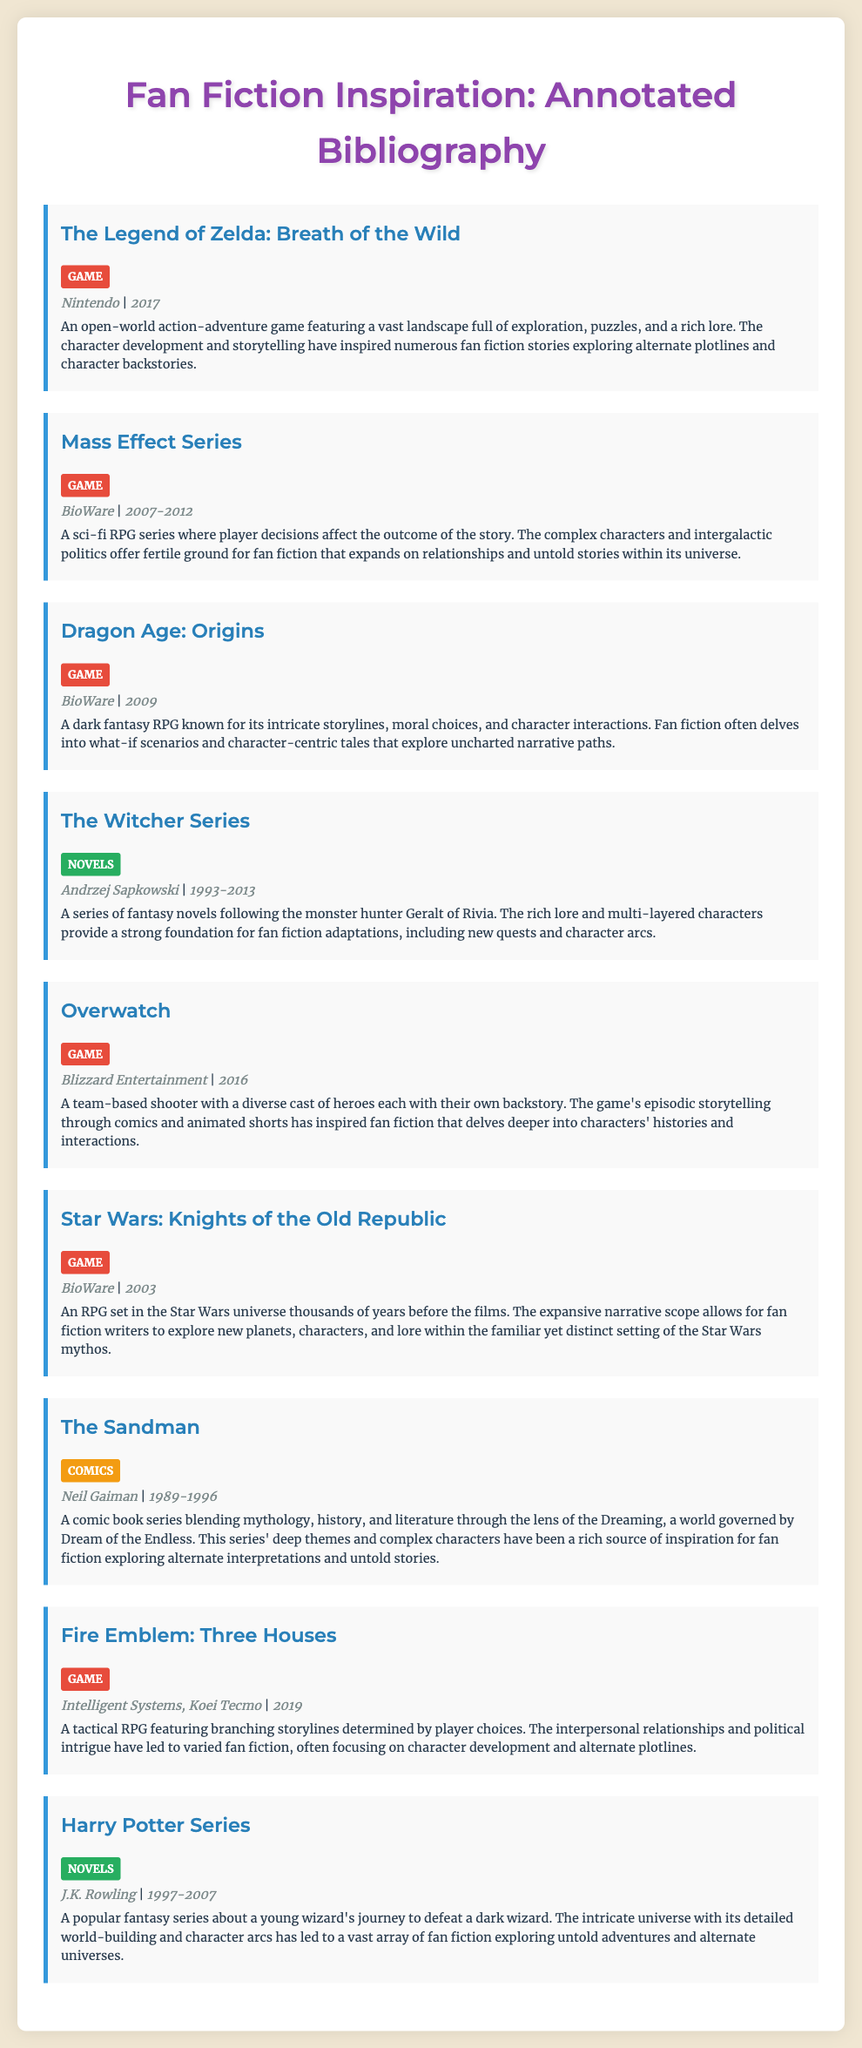What is the title of the first game listed? The first game listed is "The Legend of Zelda: Breath of the Wild."
Answer: The Legend of Zelda: Breath of the Wild Who is the creator of the Mass Effect Series? The creator of the Mass Effect Series is BioWare.
Answer: BioWare What year was Dragon Age: Origins released? Dragon Age: Origins was released in 2009.
Answer: 2009 Which novel series features the character Geralt of Rivia? The character Geralt of Rivia is from The Witcher Series.
Answer: The Witcher Series How many years does the Harry Potter Series cover in its publication? The Harry Potter Series was published from 1997 to 2007, covering a duration of 10 years.
Answer: 10 years Which game has a focus on branching storylines determined by player choices? Fire Emblem: Three Houses is known for its branching storylines determined by player choices.
Answer: Fire Emblem: Three Houses What type of media is The Sandman classified as? The Sandman is classified as Comics.
Answer: Comics What is the primary genre of the Overwatch game? Overwatch is primarily a team-based shooter.
Answer: Team-based shooter How many main games are listed in the document? There are seven main games listed in the document.
Answer: Seven 